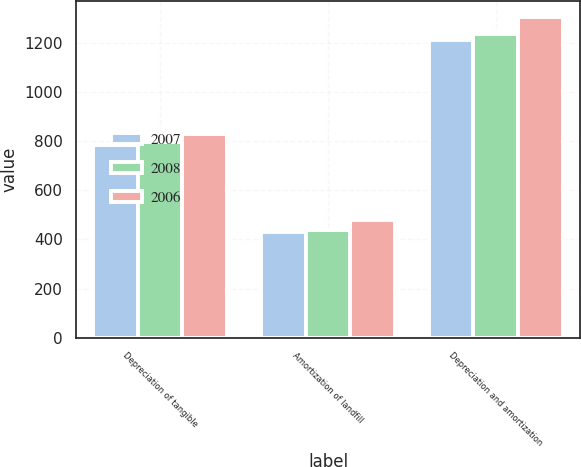Convert chart. <chart><loc_0><loc_0><loc_500><loc_500><stacked_bar_chart><ecel><fcel>Depreciation of tangible<fcel>Amortization of landfill<fcel>Depreciation and amortization<nl><fcel>2007<fcel>785<fcel>429<fcel>1214<nl><fcel>2008<fcel>796<fcel>440<fcel>1236<nl><fcel>2006<fcel>829<fcel>479<fcel>1308<nl></chart> 